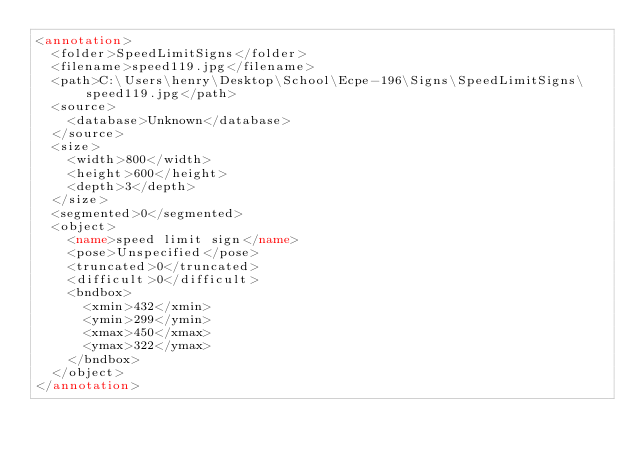<code> <loc_0><loc_0><loc_500><loc_500><_XML_><annotation>
	<folder>SpeedLimitSigns</folder>
	<filename>speed119.jpg</filename>
	<path>C:\Users\henry\Desktop\School\Ecpe-196\Signs\SpeedLimitSigns\speed119.jpg</path>
	<source>
		<database>Unknown</database>
	</source>
	<size>
		<width>800</width>
		<height>600</height>
		<depth>3</depth>
	</size>
	<segmented>0</segmented>
	<object>
		<name>speed limit sign</name>
		<pose>Unspecified</pose>
		<truncated>0</truncated>
		<difficult>0</difficult>
		<bndbox>
			<xmin>432</xmin>
			<ymin>299</ymin>
			<xmax>450</xmax>
			<ymax>322</ymax>
		</bndbox>
	</object>
</annotation>
</code> 